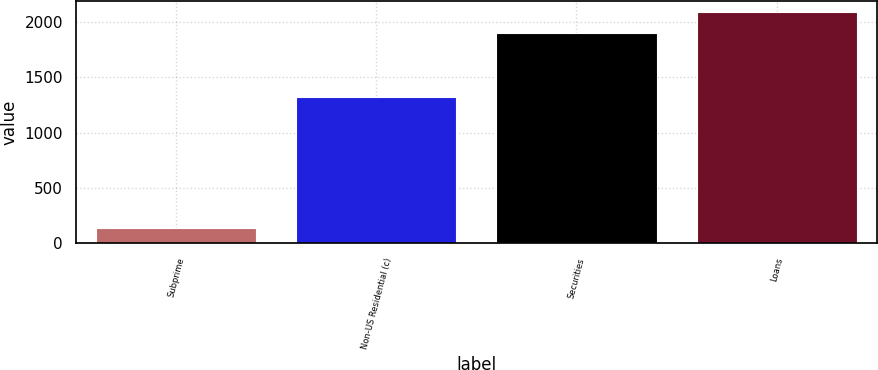<chart> <loc_0><loc_0><loc_500><loc_500><bar_chart><fcel>Subprime<fcel>Non-US Residential (c)<fcel>Securities<fcel>Loans<nl><fcel>137<fcel>1321<fcel>1898<fcel>2087.8<nl></chart> 